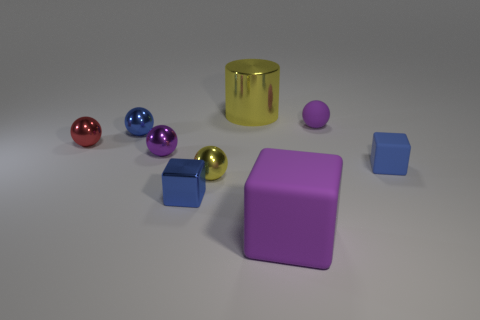What size is the yellow cylinder that is made of the same material as the red object?
Offer a terse response. Large. There is a metallic block; is it the same color as the cube behind the shiny cube?
Your response must be concise. Yes. Are there an equal number of tiny red balls that are right of the small purple metallic object and small matte spheres?
Ensure brevity in your answer.  No. How many shiny cylinders have the same size as the red ball?
Make the answer very short. 0. The small metallic thing that is the same color as the metal cube is what shape?
Make the answer very short. Sphere. Are there any blue matte cubes?
Give a very brief answer. Yes. There is a small blue thing that is to the right of the big cube; is its shape the same as the small blue metal object that is to the right of the small purple shiny object?
Give a very brief answer. Yes. What number of big things are either brown matte cubes or blue shiny objects?
Give a very brief answer. 0. The other big thing that is the same material as the red object is what shape?
Provide a succinct answer. Cylinder. Does the red thing have the same shape as the big rubber object?
Your response must be concise. No. 